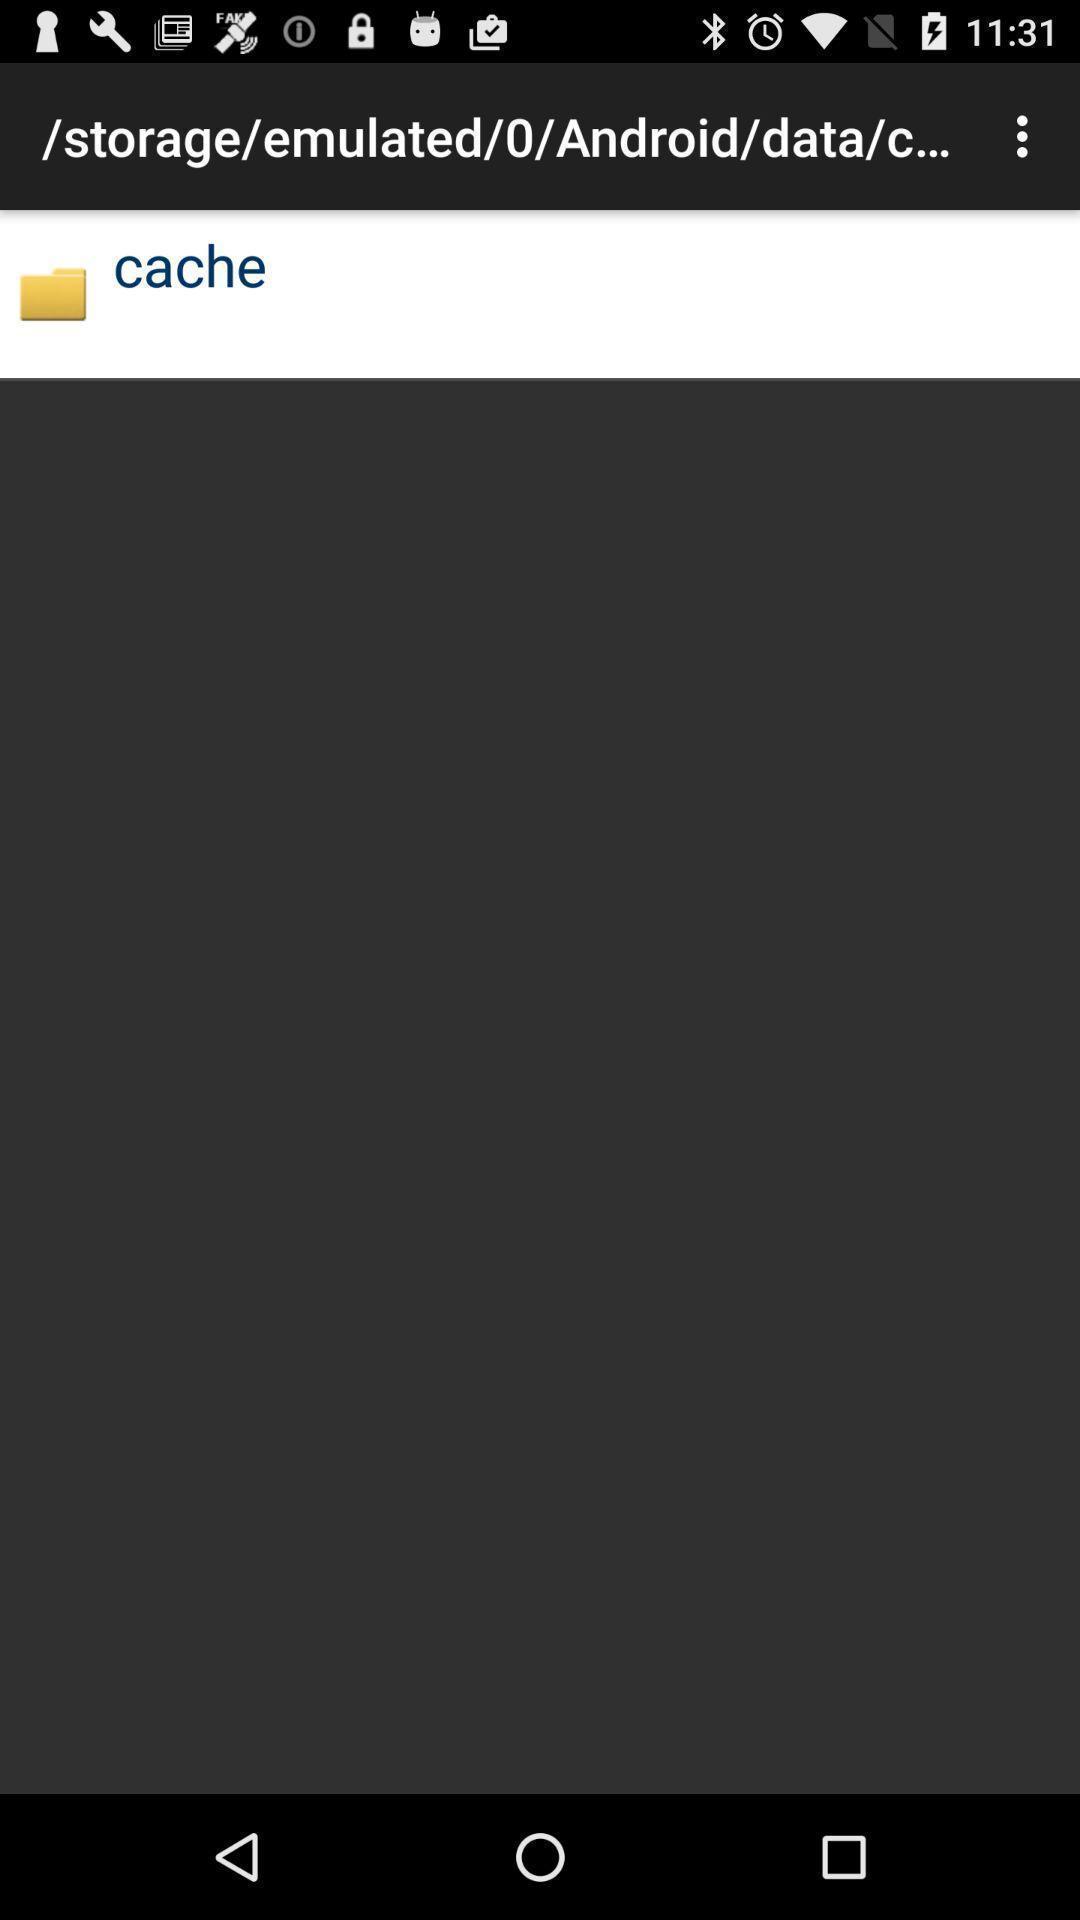Provide a textual representation of this image. Website of storage emulated in cache. 